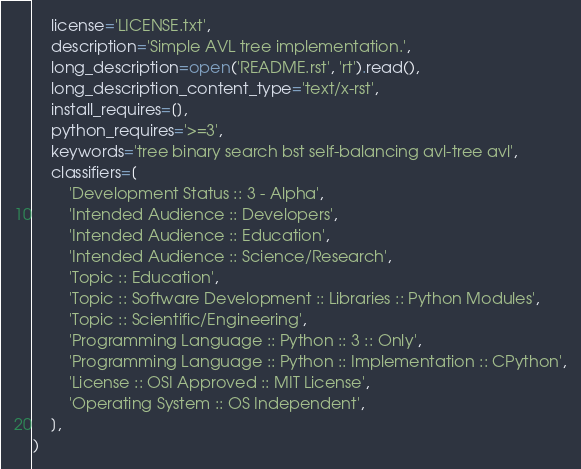<code> <loc_0><loc_0><loc_500><loc_500><_Python_>    license='LICENSE.txt',
    description='Simple AVL tree implementation.',
    long_description=open('README.rst', 'rt').read(),
    long_description_content_type='text/x-rst',
    install_requires=[],
    python_requires='>=3',
    keywords='tree binary search bst self-balancing avl-tree avl',
    classifiers=[
        'Development Status :: 3 - Alpha',
        'Intended Audience :: Developers',
        'Intended Audience :: Education',
        'Intended Audience :: Science/Research',
        'Topic :: Education',
        'Topic :: Software Development :: Libraries :: Python Modules',
        'Topic :: Scientific/Engineering',
        'Programming Language :: Python :: 3 :: Only',
        'Programming Language :: Python :: Implementation :: CPython',
        'License :: OSI Approved :: MIT License',
        'Operating System :: OS Independent',
    ],
)
</code> 